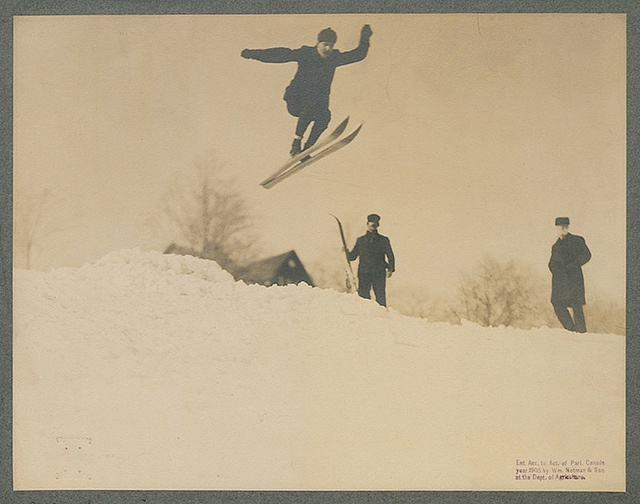Describe the objects in this image and their specific colors. I can see people in gray and tan tones, people in gray and tan tones, people in gray, darkgreen, and tan tones, skis in gray and tan tones, and skis in gray and tan tones in this image. 